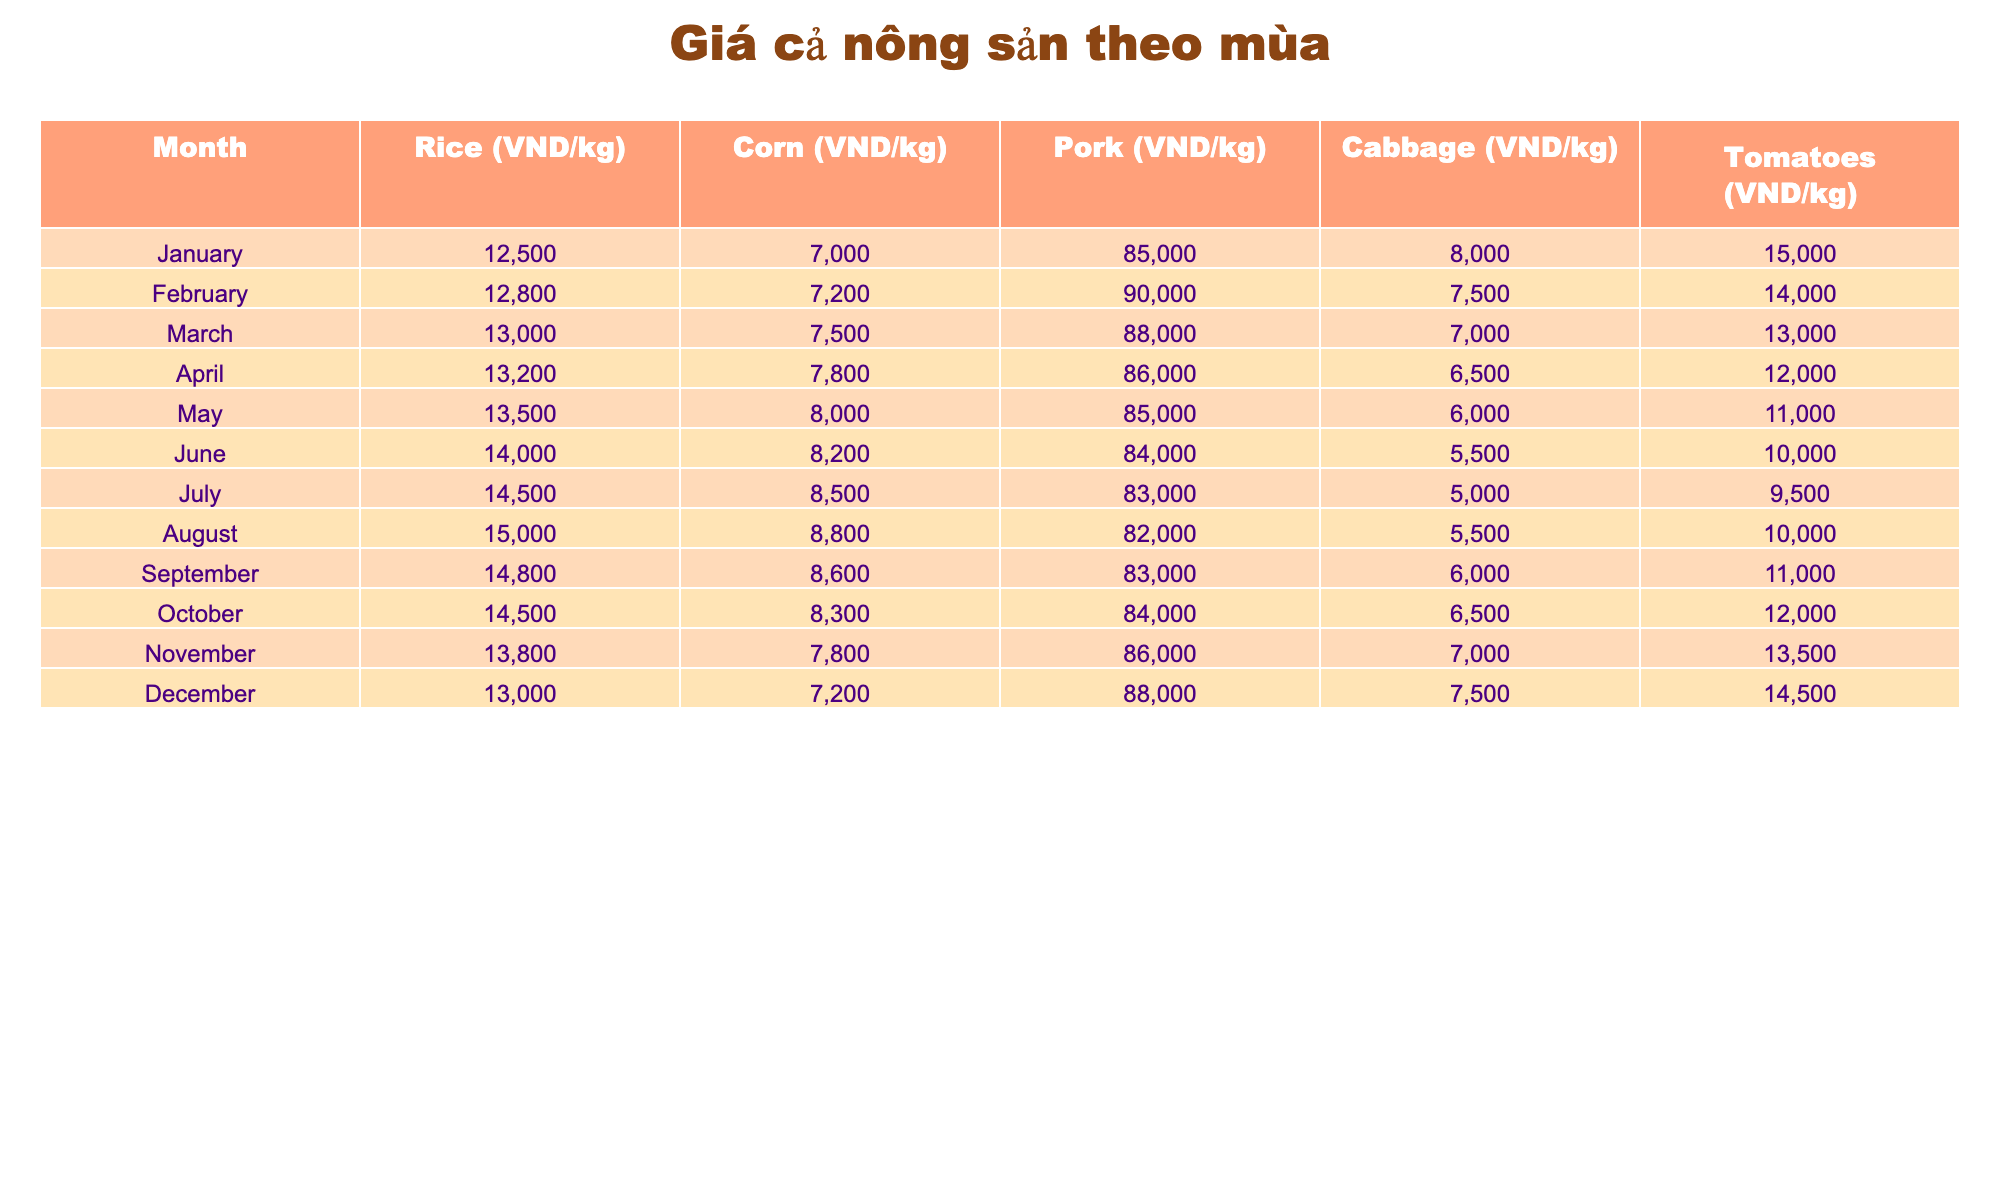What is the price of rice in June? From the table, I can directly see the value listed under the June column for rice. It reads 14000 VND/kg.
Answer: 14000 VND/kg Which month has the highest price for pork? Looking at the pork prices in each month listed in the table, I see the highest value is 90000 VND/kg in February.
Answer: 90000 VND/kg How much did the price of corn change from January to December? The corn price in January is 7000 VND/kg and in December it is 7200 VND/kg. The change can be calculated as 7200 - 7000 = 200 VND/kg.
Answer: 200 VND/kg Is the price of tomatoes higher in July than in May? In July, the price of tomatoes is 9500 VND/kg while in May it is 11000 VND/kg. Since 9500 is less than 11000, the statement is false.
Answer: No What is the average price of cabbage from January to June? I will sum up the cabbage prices from January (8000), February (7500), March (7000), April (6500), May (6000), and June (5500). The total becomes 8000 + 7500 + 7000 + 6500 + 6000 + 5500 = 40500. To find the average, divide by 6: 40500 / 6 = 6750 VND/kg.
Answer: 6750 VND/kg In which month is the price of rice less than 14000 VND/kg? I check each month's rice price starting from January to July. The prices below 14000 VND/kg are seen in January (12500), February (12800), March (13000), April (13200), and May (13500), while June and July exceed it.
Answer: January, February, March, April, May What is the difference in pork price between the highest month and the lowest month? The highest price for pork is 90000 VND/kg in February and the lowest is 82000 VND/kg in August. To find the difference, I calculate 90000 - 82000 = 8000 VND/kg.
Answer: 8000 VND/kg Is the price of rice consistently increasing throughout the year? By looking at the rice prices in each month, I check for any decreases. January (12500), February (12800), March (13000), April (13200), May (13500), June (14000), July (14500), August (15000), September (14800), October (14500), November (13800), and December (13000). There are decreases in September, October, November, and December. Therefore, it is not consistent.
Answer: No What is the total price of corn for the entire year? I will sum the corn prices from each month: 7000 + 7200 + 7500 + 7800 + 8000 + 8200 + 8500 + 8800 + 8600 + 8300 + 7800 + 7200. This calculation gives a total of 93300 VND for the year.
Answer: 93300 VND 